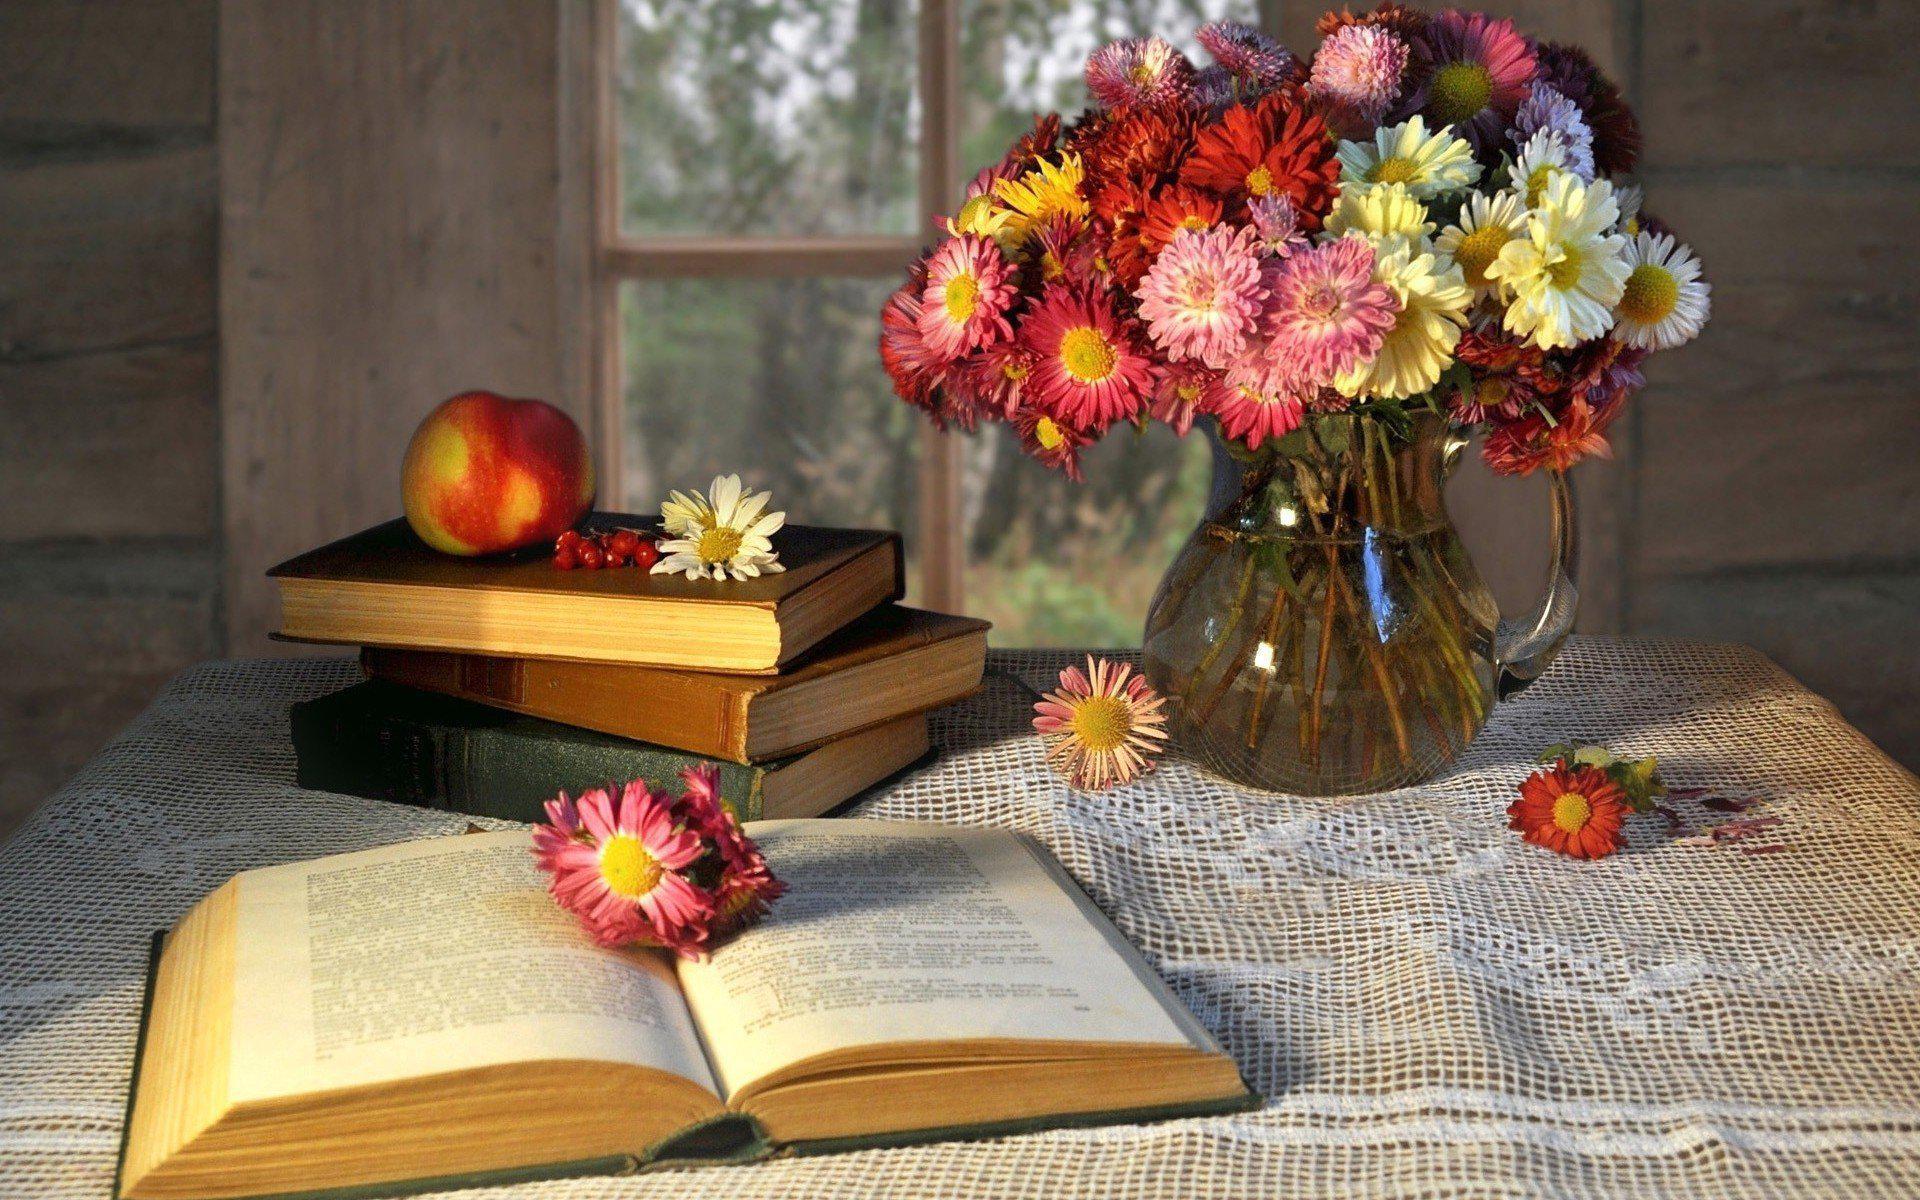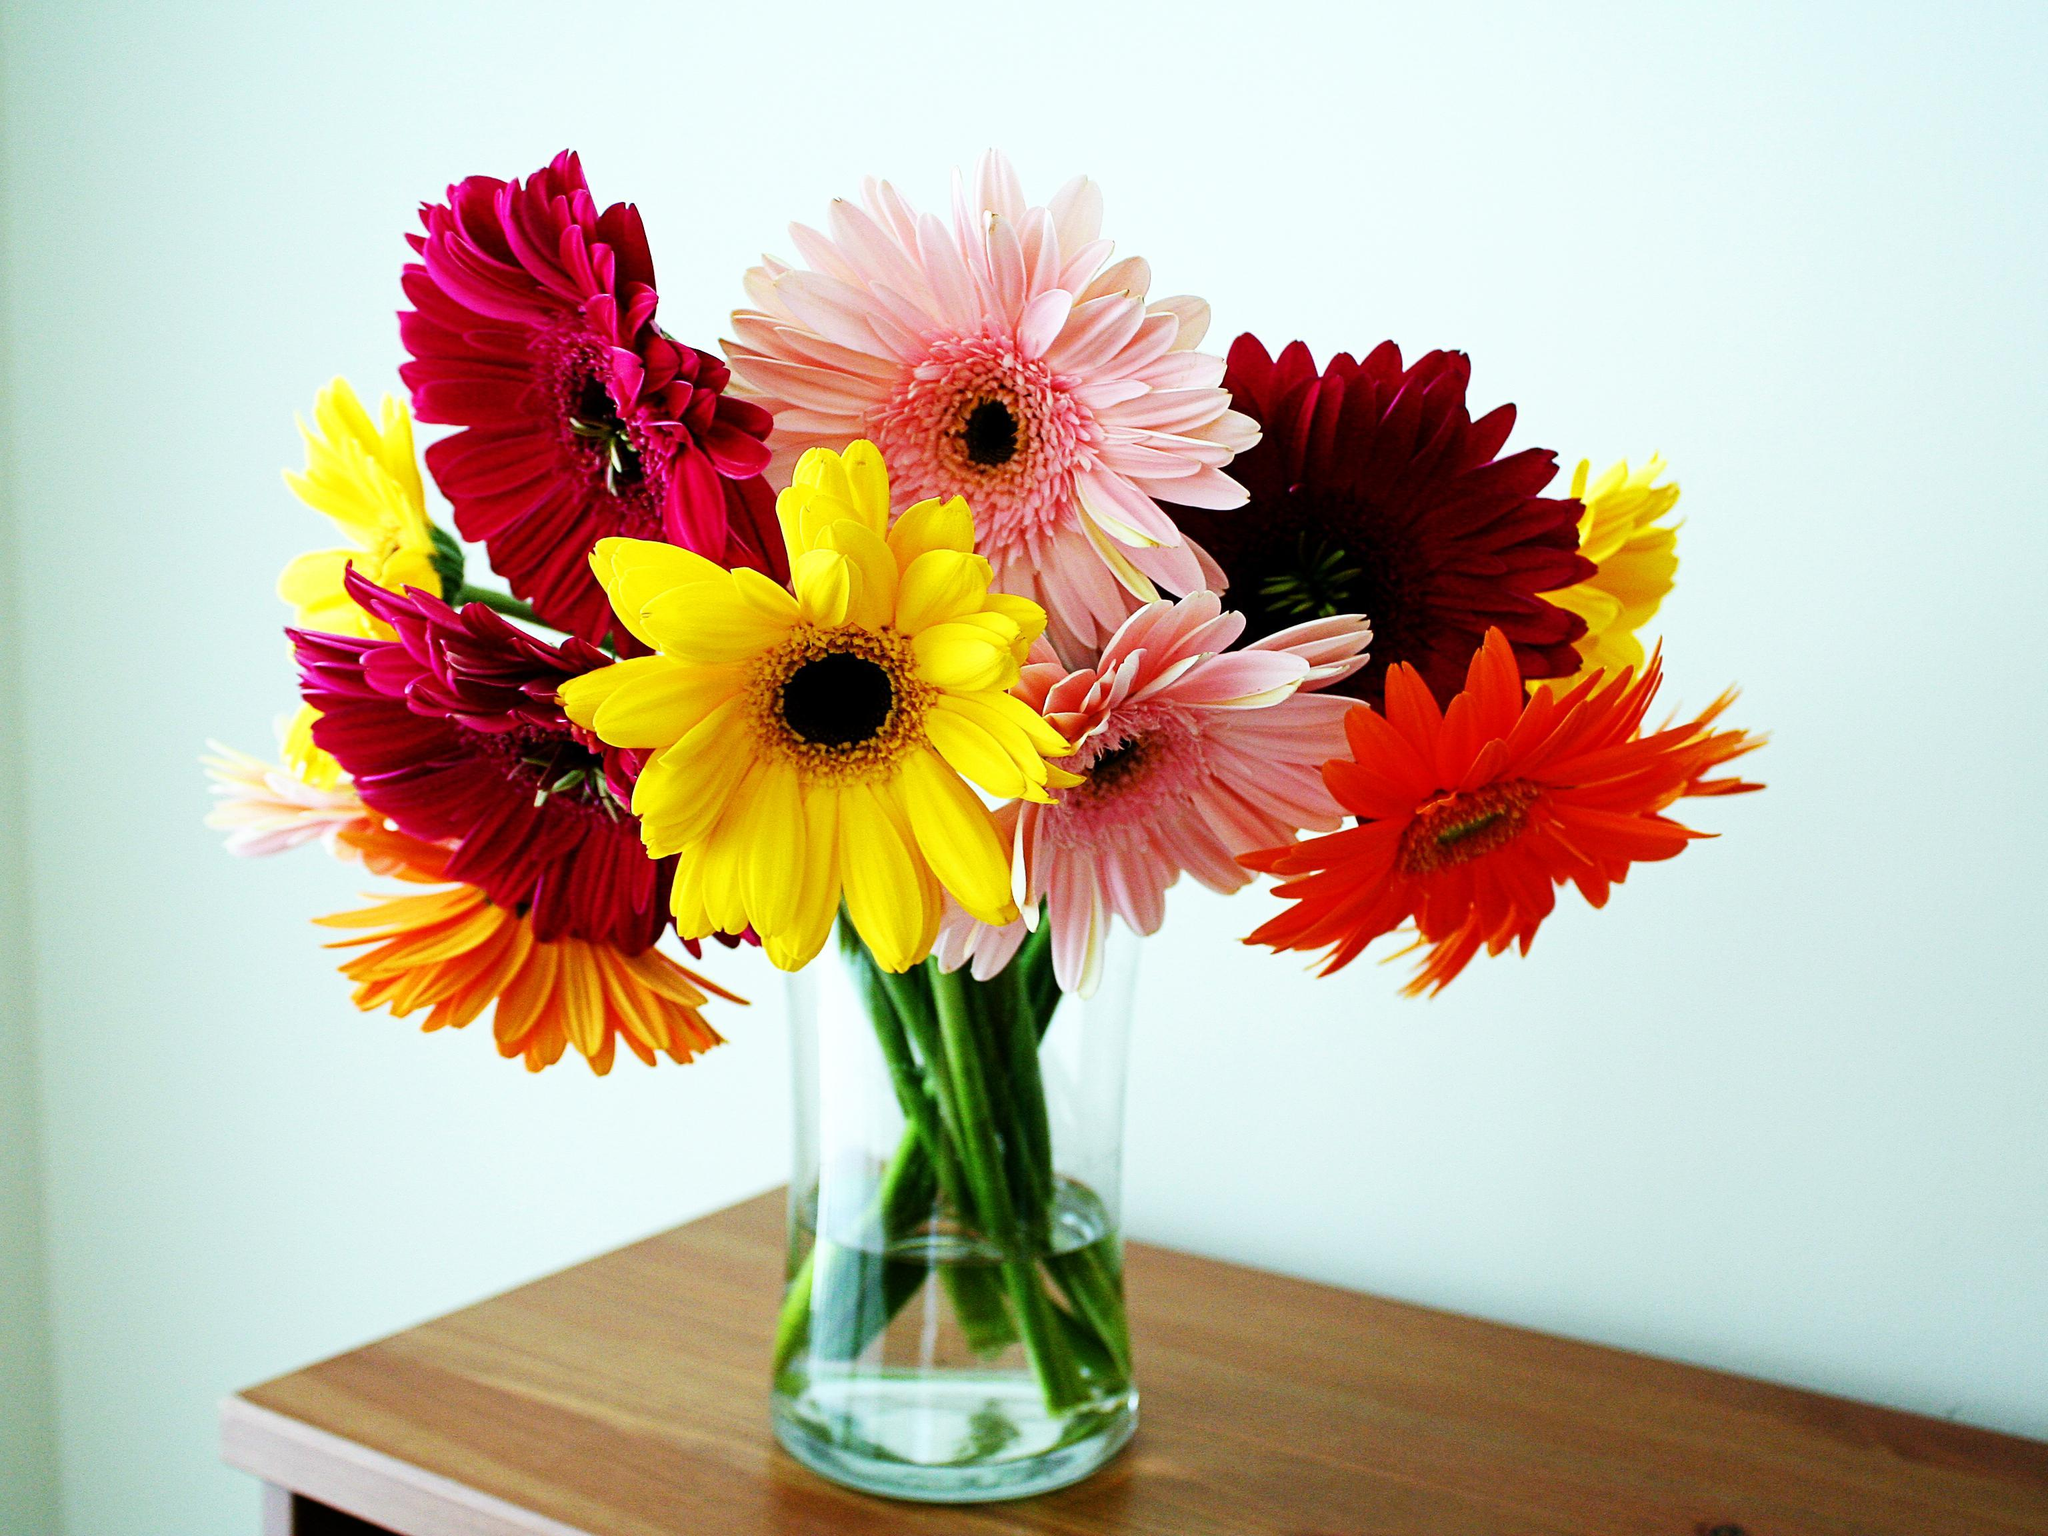The first image is the image on the left, the second image is the image on the right. For the images shown, is this caption "There are books with the flowers." true? Answer yes or no. Yes. The first image is the image on the left, the second image is the image on the right. Analyze the images presented: Is the assertion "Each image contains exactly one vase of flowers, and the vase in one image contains multiple flower colors, while the other contains flowers with a single petal color." valid? Answer yes or no. No. 